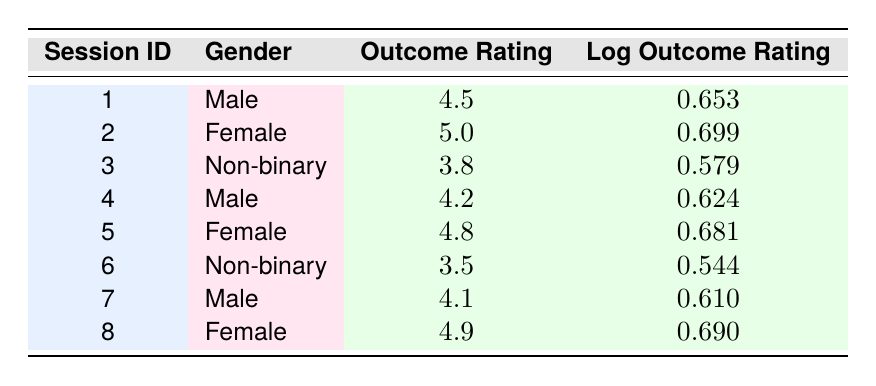What is the outcome rating for the session with ID 2? The table shows the session ID in the first column and the corresponding outcome rating in the third column. For session ID 2, the outcome rating is listed as 5.0.
Answer: 5.0 What is the log outcome rating for Female therapy sessions? We look for all rows where the gender is "Female." There are two sessions for Females: session IDs 2 and 5. The log outcome ratings for these sessions are 0.699 and 0.681.
Answer: The log outcome ratings for Female sessions are 0.699 and 0.681 What is the average outcome rating for Male sessions? The table has three sessions for Males with outcome ratings: 4.5, 4.2, and 4.1. First, we sum these ratings: 4.5 + 4.2 + 4.1 = 12.8. Then, we divide by the number of Male sessions (3): 12.8 / 3 = 4.27.
Answer: 4.27 Is there a session with an outcome rating of 3.5? The table lists outcome ratings for all sessions. We check each rating and find that session ID 6 has an outcome rating of 3.5. Therefore, the answer is yes.
Answer: Yes Which gender had the highest average log outcome rating? We first calculate the average log outcome rating for each gender. For Males: (0.653 + 0.624 + 0.610) / 3 = 0.632. For Females: (0.699 + 0.681) / 2 = 0.690. For Non-binary: (0.579 + 0.544) / 2 = 0.562. Comparing these averages, Females have the highest average log outcome rating at 0.690.
Answer: Female How many sessions received a rating above 4.5? We check each outcome rating in the table and find that sessions 2 (5.0), 5 (4.8), and 8 (4.9) have ratings above 4.5. So, there are three sessions above this threshold.
Answer: 3 What is the difference between the maximum and minimum log outcome ratings? The maximum log outcome rating is 0.699 (session 2, Female) and the minimum is 0.544 (session 6, Non-binary). To find the difference: 0.699 - 0.544 = 0.155.
Answer: 0.155 Is the average outcome rating for Non-binary sessions lower than 4.0? There are two sessions for Non-binary individuals with outcome ratings of 3.8 and 3.5. The average is (3.8 + 3.5) / 2 = 3.65. Since 3.65 is lower than 4.0, the answer is yes.
Answer: Yes 